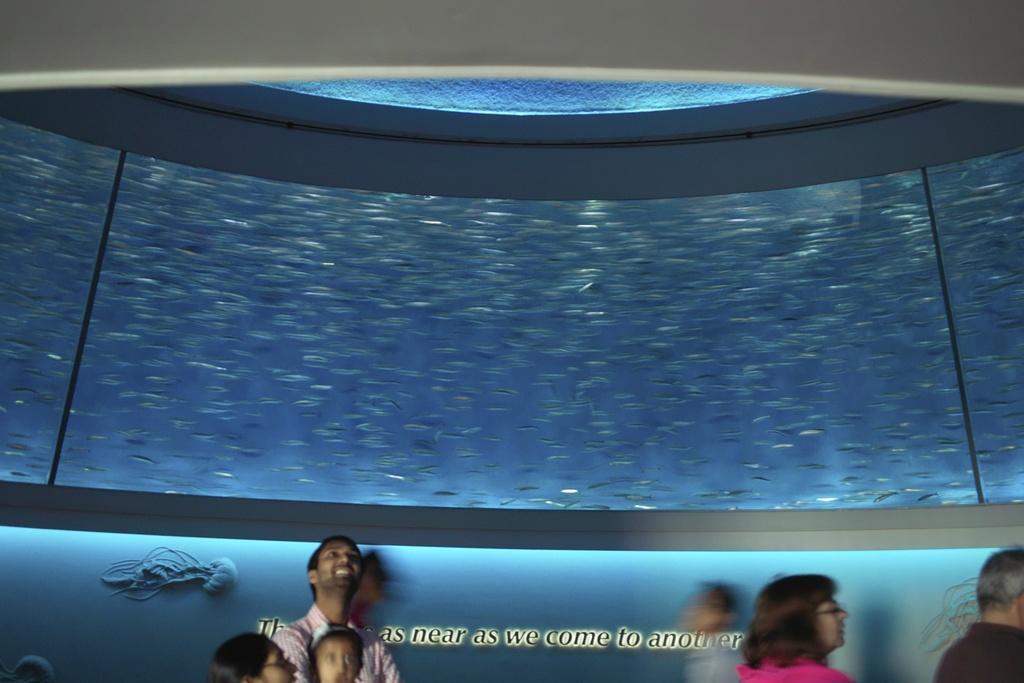Could you give a brief overview of what you see in this image? In this image I can see the group of people with different color dresses. In-front of these people there is an aquarium which is in blue color. And I can see the fish inside an aquarium. 